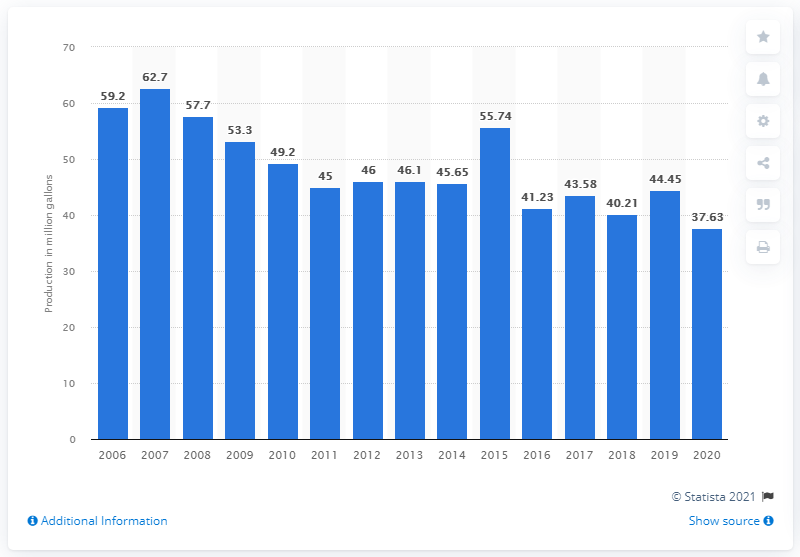Draw attention to some important aspects in this diagram. In 2020, approximately 37.63 million gallons of sherbet were produced in the United States. 